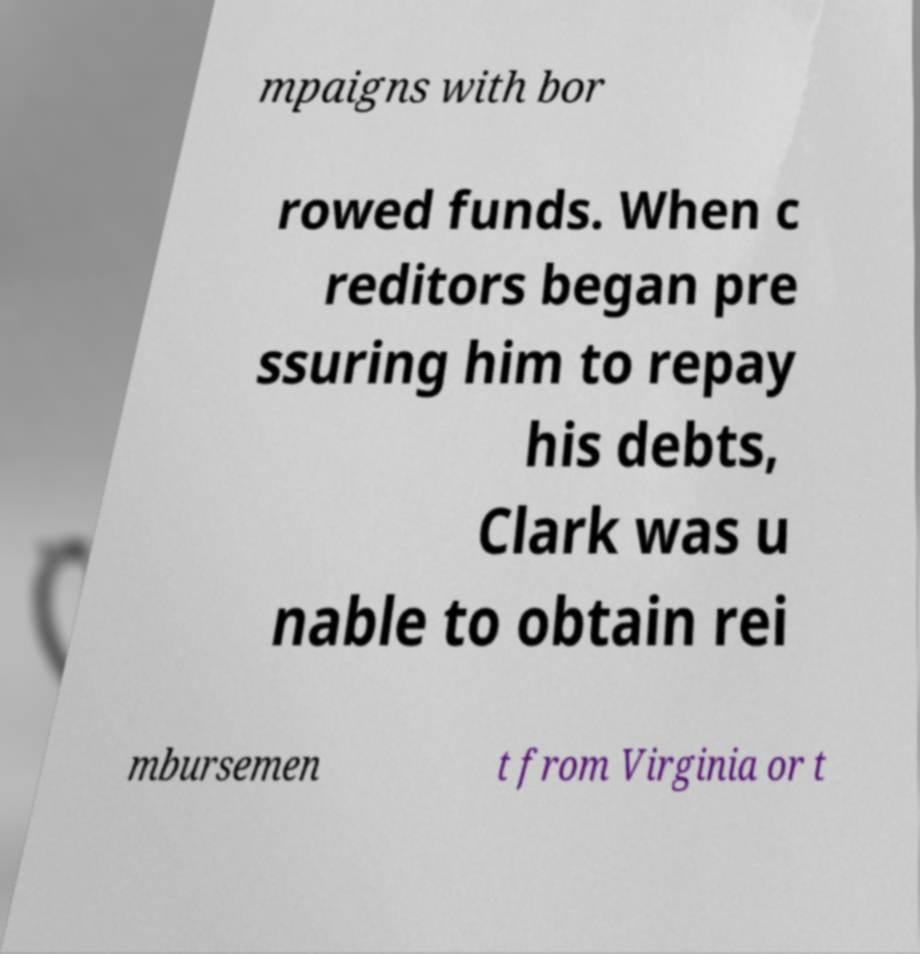Could you assist in decoding the text presented in this image and type it out clearly? mpaigns with bor rowed funds. When c reditors began pre ssuring him to repay his debts, Clark was u nable to obtain rei mbursemen t from Virginia or t 